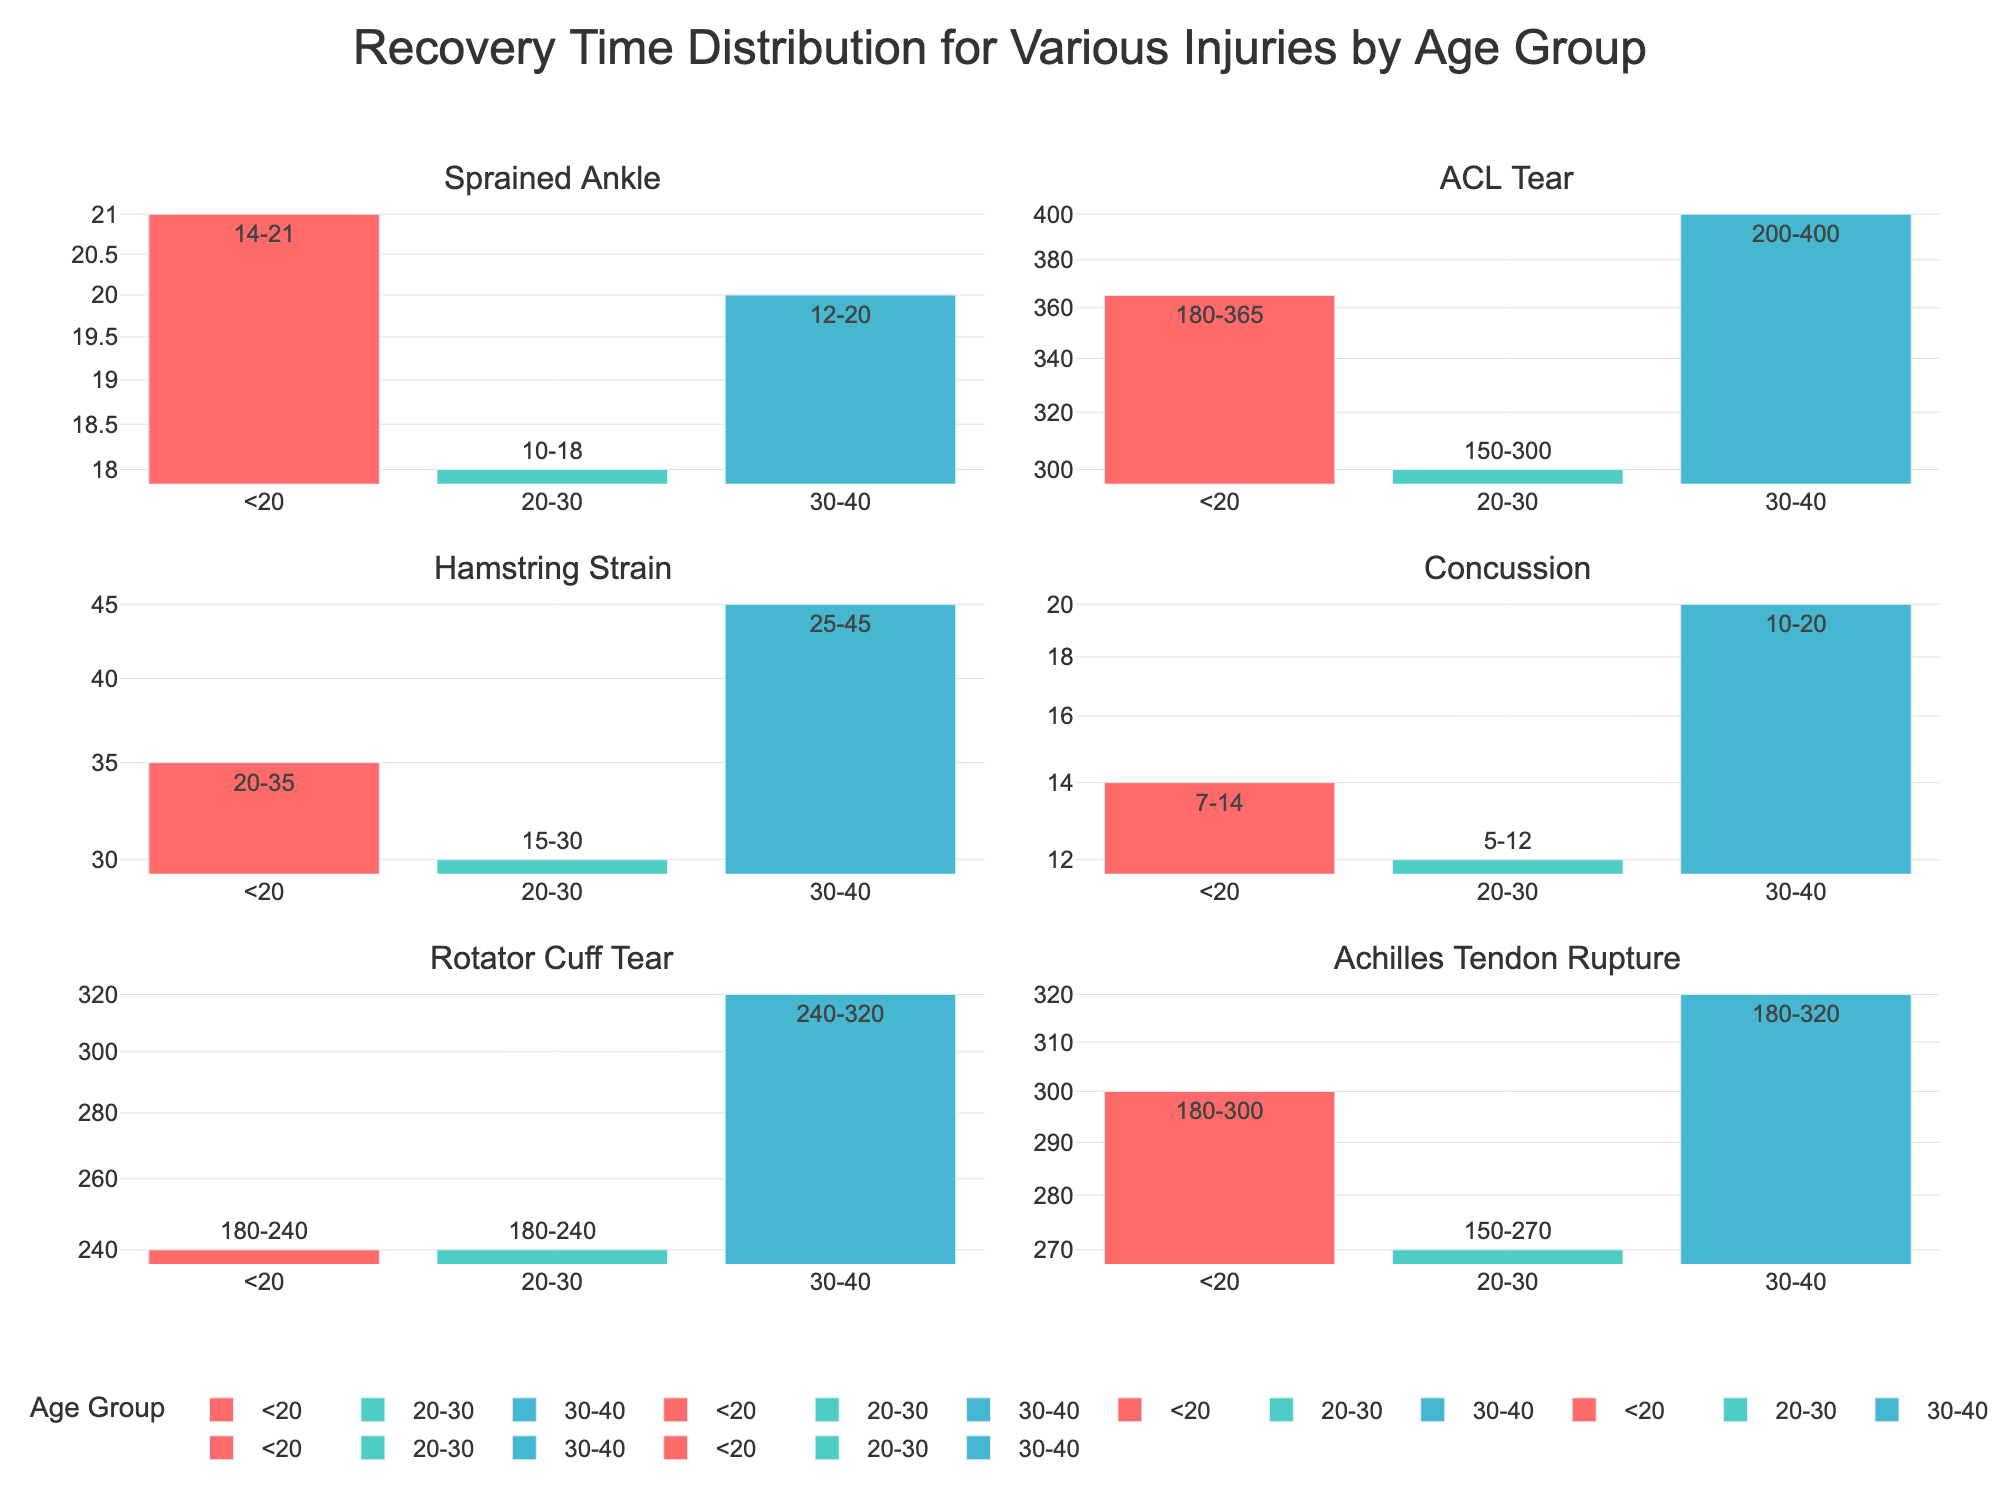What is the subtitle for the "Sprained Ankle" subplot? The figure is divided into subplots, each corresponding to a specific injury type. The title of the subplot for "Sprained Ankle" is explicitly given.
Answer: Sprained Ankle Which age group has the longest maximum recovery time for an ACL tear? In the "ACL Tear" subplot, visually compare the lengths of the bars corresponding to different age groups and identify the one with the tallest bar. This bar represents the longest maximum recovery time.
Answer: 30-40 What is the range of recovery times for a concussion in the 20-30 age group? Locate the "Concussion" subplot and look for the bar representing the 20-30 age group. The text annotation on the bar provides the range of recovery times.
Answer: 5-12 days How does the recovery time for a rotator cuff tear compare between the <20 and 30-40 age groups? In the "Rotator Cuff Tear" subplot, compare the heights of the bars for the <20 and 30-40 age groups. The 30-40 age group has a range of 240-320 days, while the <20 age group has a range of 180-240 days. The 30-40 age group has a longer recovery time.
Answer: Longer for 30-40 Which injury has the shortest minimum recovery time and for which age group? Examine all subplots and identify the bar with the shortest height representing the minimum recovery time. This value is located in the "Concussion" subplot, specifically for the 20-30 age group. The minimum recovery time is 5 days.
Answer: Concussion, 20-30 What is the visual pattern of recovery times across different age groups for hamstring strains? Analyze the bar heights in the "Hamstring Strain" subplot for each age group. Identify if there is an increasing, decreasing, or inconsistent pattern. The 20-30 age group has the shortest recovery time, followed by <20, and the 30-40 age group with the longest recovery time, showing an increasing trend.
Answer: Increasing trend Which age group has the most similar recovery times across all injury types? For each injury subplot, look at the bars for each age group and compare their heights. The <20 age group generally has similar-looking bars across most injuries, indicating they have the most consistent recovery times.
Answer: <20 On a log scale, what difference in recovery time can you observe between a sprained ankle and an Achilles tendon rupture for the 20-30 age group? In the 20-30 age group, compare the heights of the bars in the "Sprained Ankle" and "Achilles Tendon Rupture" subplots. The sprained ankle has a 10-18 days recovery time, while the Achilles tendon rupture has a 150-270 days recovery time. This indicates a significant difference, with Achilles tendon rupture having a far longer recovery time.
Answer: Significant, Achilles tendon rupture is much longer What does the shape of the subplots tell you about the variance in recovery times for different injuries? Analyze the bar heights within each subplot. Large differences (or heights) between bars within a subplot indicate high variance in recovery times across age groups for that injury. Smaller differences indicate low variance. Notable differences between injuries show varied recovery times for different types of injuries.
Answer: High variance across injuries and age groups 